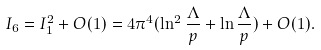<formula> <loc_0><loc_0><loc_500><loc_500>I _ { 6 } = I _ { 1 } ^ { 2 } + O ( 1 ) = 4 \pi ^ { 4 } ( \ln ^ { 2 } \frac { \Lambda } { p } + \ln \frac { \Lambda } { p } ) + O ( 1 ) .</formula> 